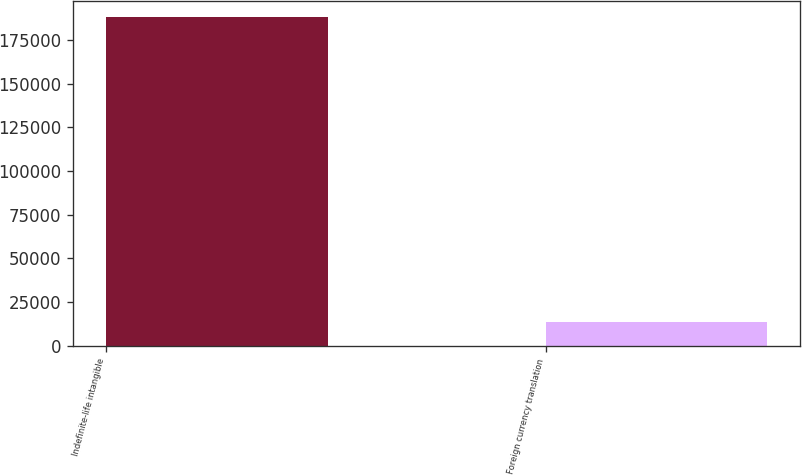Convert chart to OTSL. <chart><loc_0><loc_0><loc_500><loc_500><bar_chart><fcel>Indefinite-life intangible<fcel>Foreign currency translation<nl><fcel>188038<fcel>13753<nl></chart> 